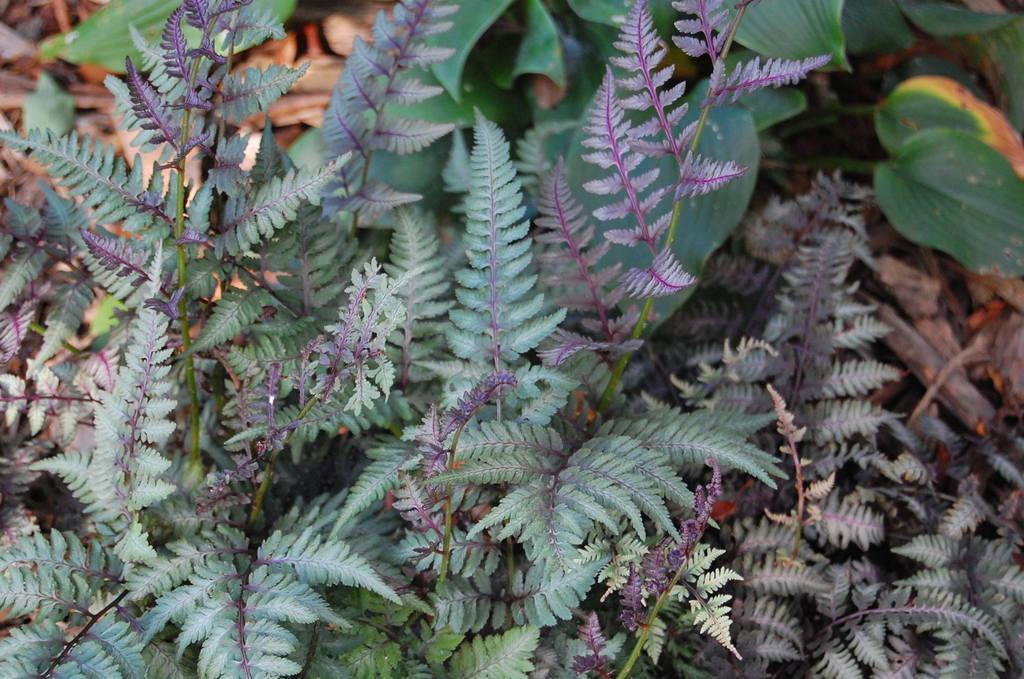In one or two sentences, can you explain what this image depicts? In this image, I can see the plants with stems and leaves. 